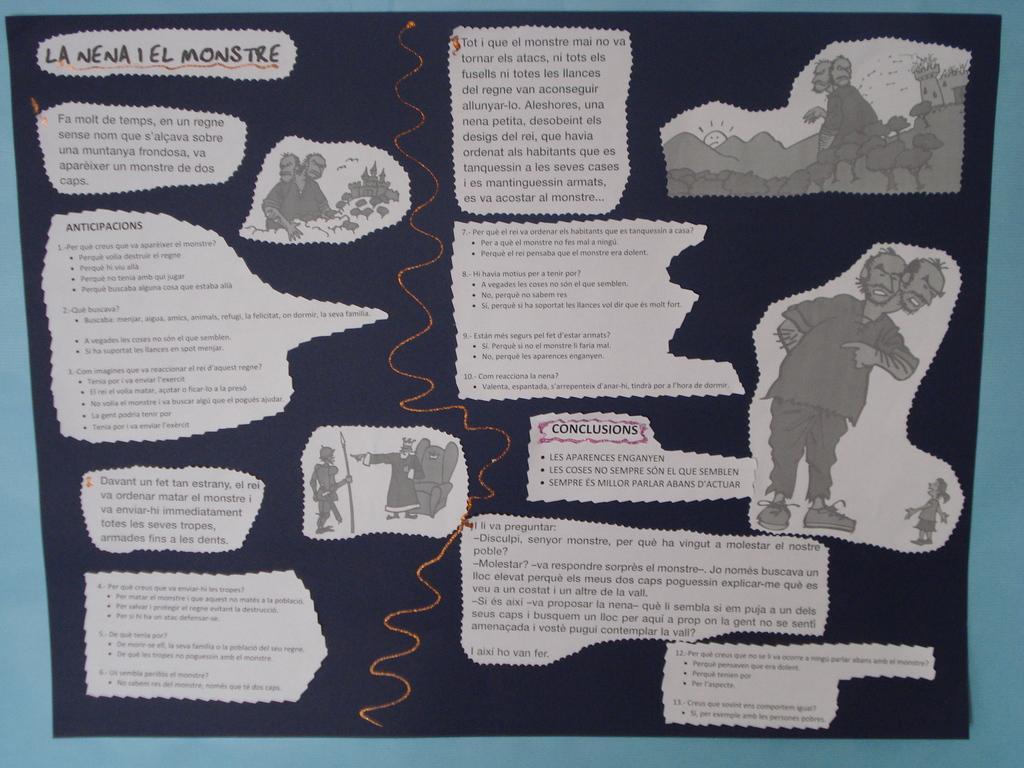Describe this image in one or two sentences. In this image we can see the black color paper with some text and images which is attached to the wall. 